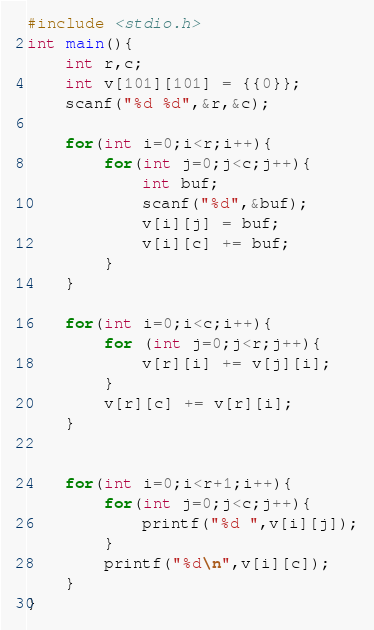<code> <loc_0><loc_0><loc_500><loc_500><_C_>#include <stdio.h>
int main(){
	int r,c;
	int v[101][101] = {{0}};
	scanf("%d %d",&r,&c);

	for(int i=0;i<r;i++){
		for(int j=0;j<c;j++){
			int buf;
			scanf("%d",&buf);
			v[i][j] = buf;
			v[i][c] += buf;
		}
	}

	for(int i=0;i<c;i++){
		for (int j=0;j<r;j++){
			v[r][i] += v[j][i];
		}
		v[r][c] += v[r][i];
	}


	for(int i=0;i<r+1;i++){
		for(int j=0;j<c;j++){
			printf("%d ",v[i][j]);
		}
		printf("%d\n",v[i][c]);
	}
}</code> 